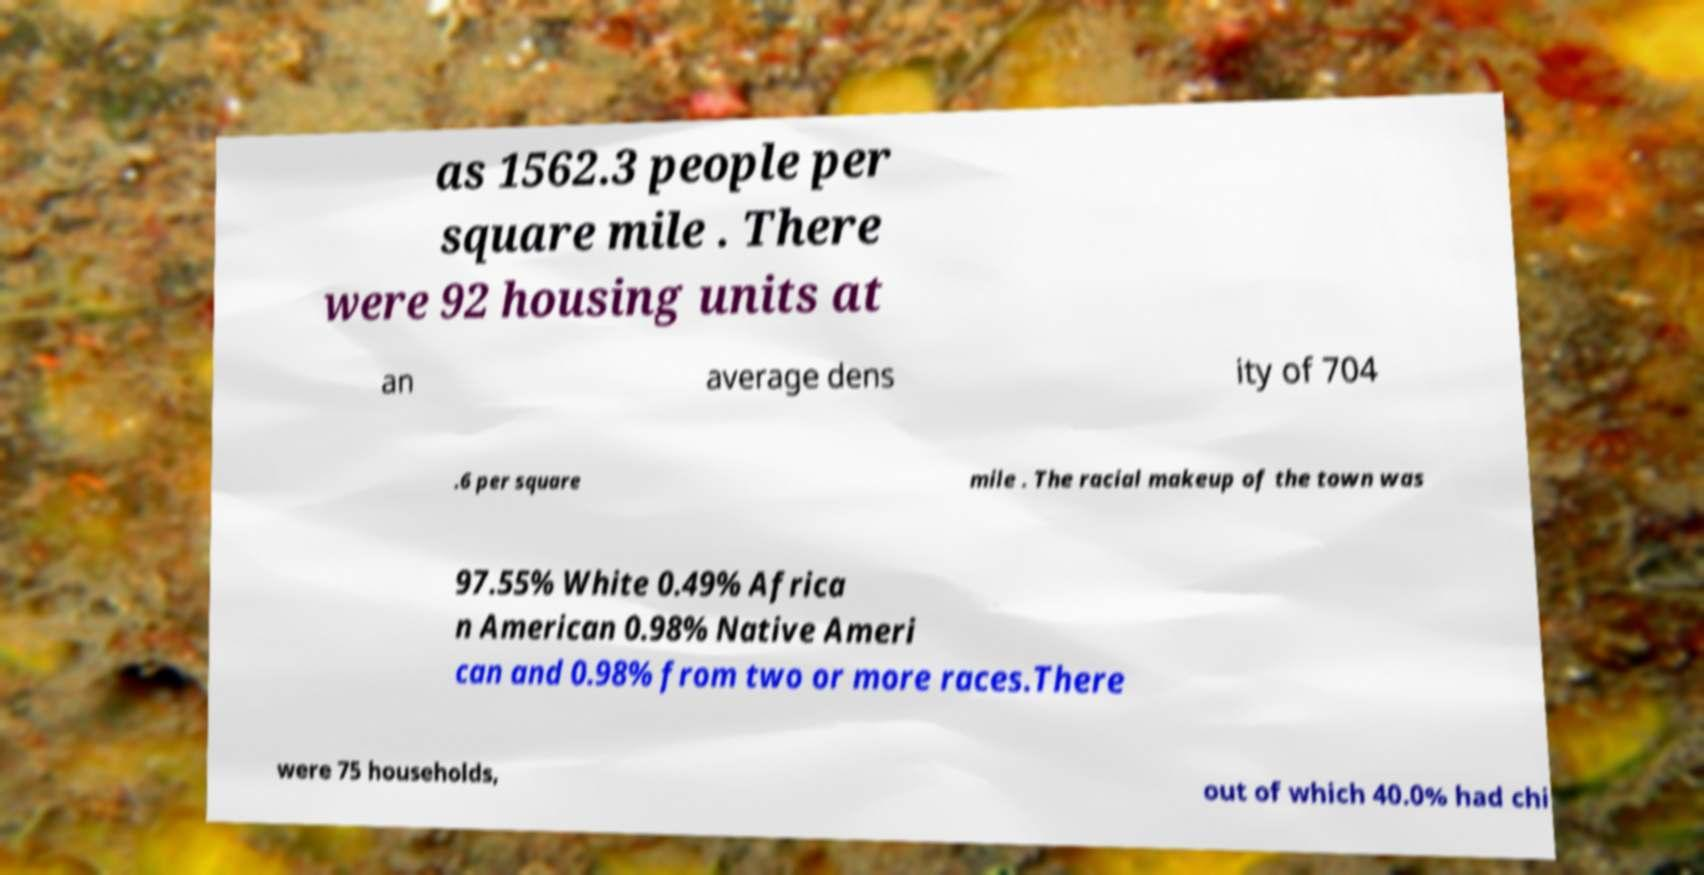I need the written content from this picture converted into text. Can you do that? as 1562.3 people per square mile . There were 92 housing units at an average dens ity of 704 .6 per square mile . The racial makeup of the town was 97.55% White 0.49% Africa n American 0.98% Native Ameri can and 0.98% from two or more races.There were 75 households, out of which 40.0% had chi 